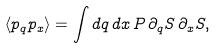<formula> <loc_0><loc_0><loc_500><loc_500>\langle p _ { q } p _ { x } \rangle = \int d q \, d x \, P \, \partial _ { q } S \, \partial _ { x } S ,</formula> 